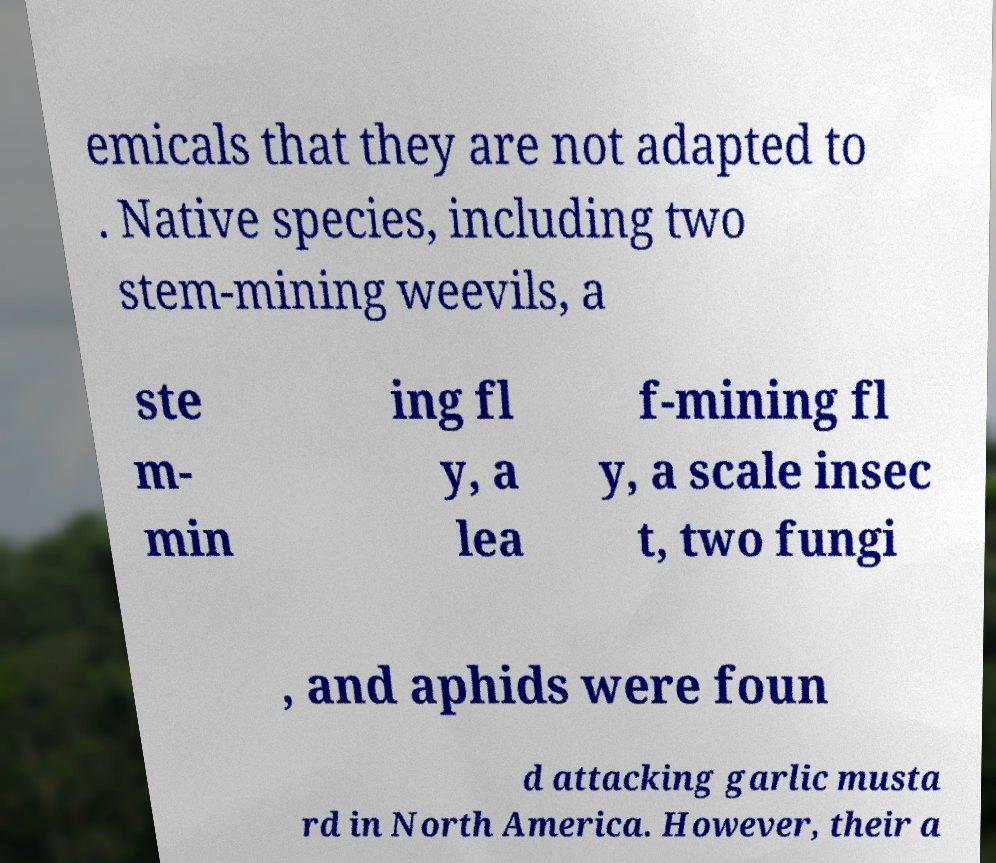For documentation purposes, I need the text within this image transcribed. Could you provide that? emicals that they are not adapted to . Native species, including two stem-mining weevils, a ste m- min ing fl y, a lea f-mining fl y, a scale insec t, two fungi , and aphids were foun d attacking garlic musta rd in North America. However, their a 